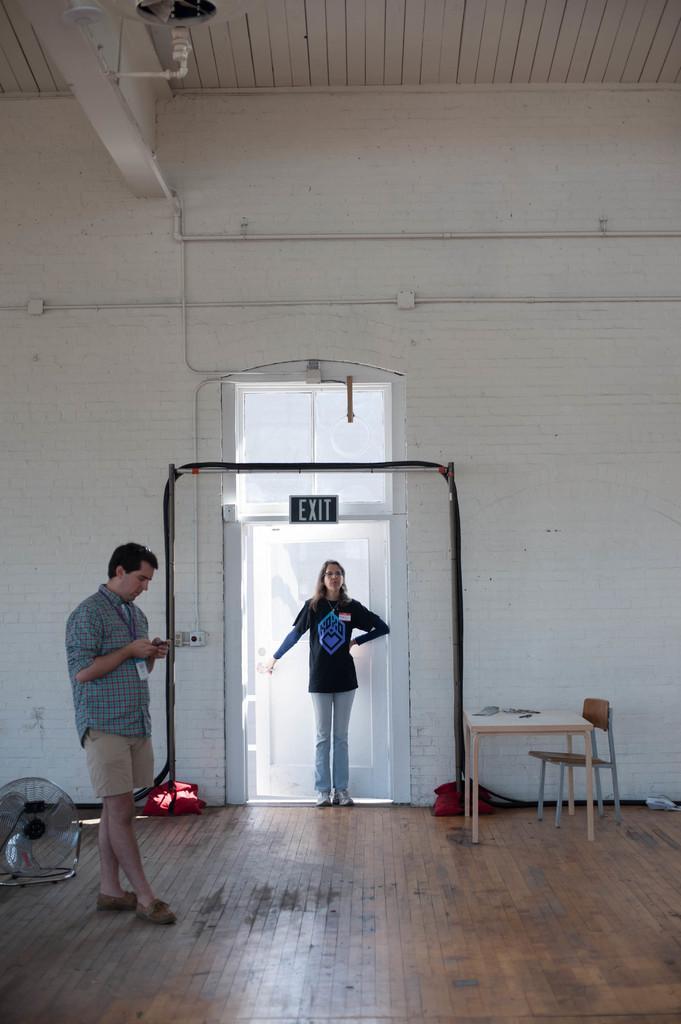How would you summarize this image in a sentence or two? In this image in the center there is one woman who is standing near the door and on the left side there is one man who is standing and on the top there is ceiling and in the middle there is a wall and on the floor there is a table and chair, on the left side there is a fan. 